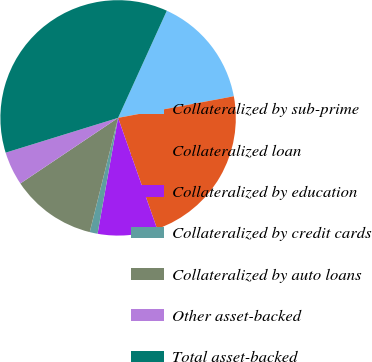Convert chart. <chart><loc_0><loc_0><loc_500><loc_500><pie_chart><fcel>Collateralized by sub-prime<fcel>Collateralized loan<fcel>Collateralized by education<fcel>Collateralized by credit cards<fcel>Collateralized by auto loans<fcel>Other asset-backed<fcel>Total asset-backed<nl><fcel>15.27%<fcel>22.56%<fcel>8.17%<fcel>1.08%<fcel>11.72%<fcel>4.63%<fcel>36.57%<nl></chart> 